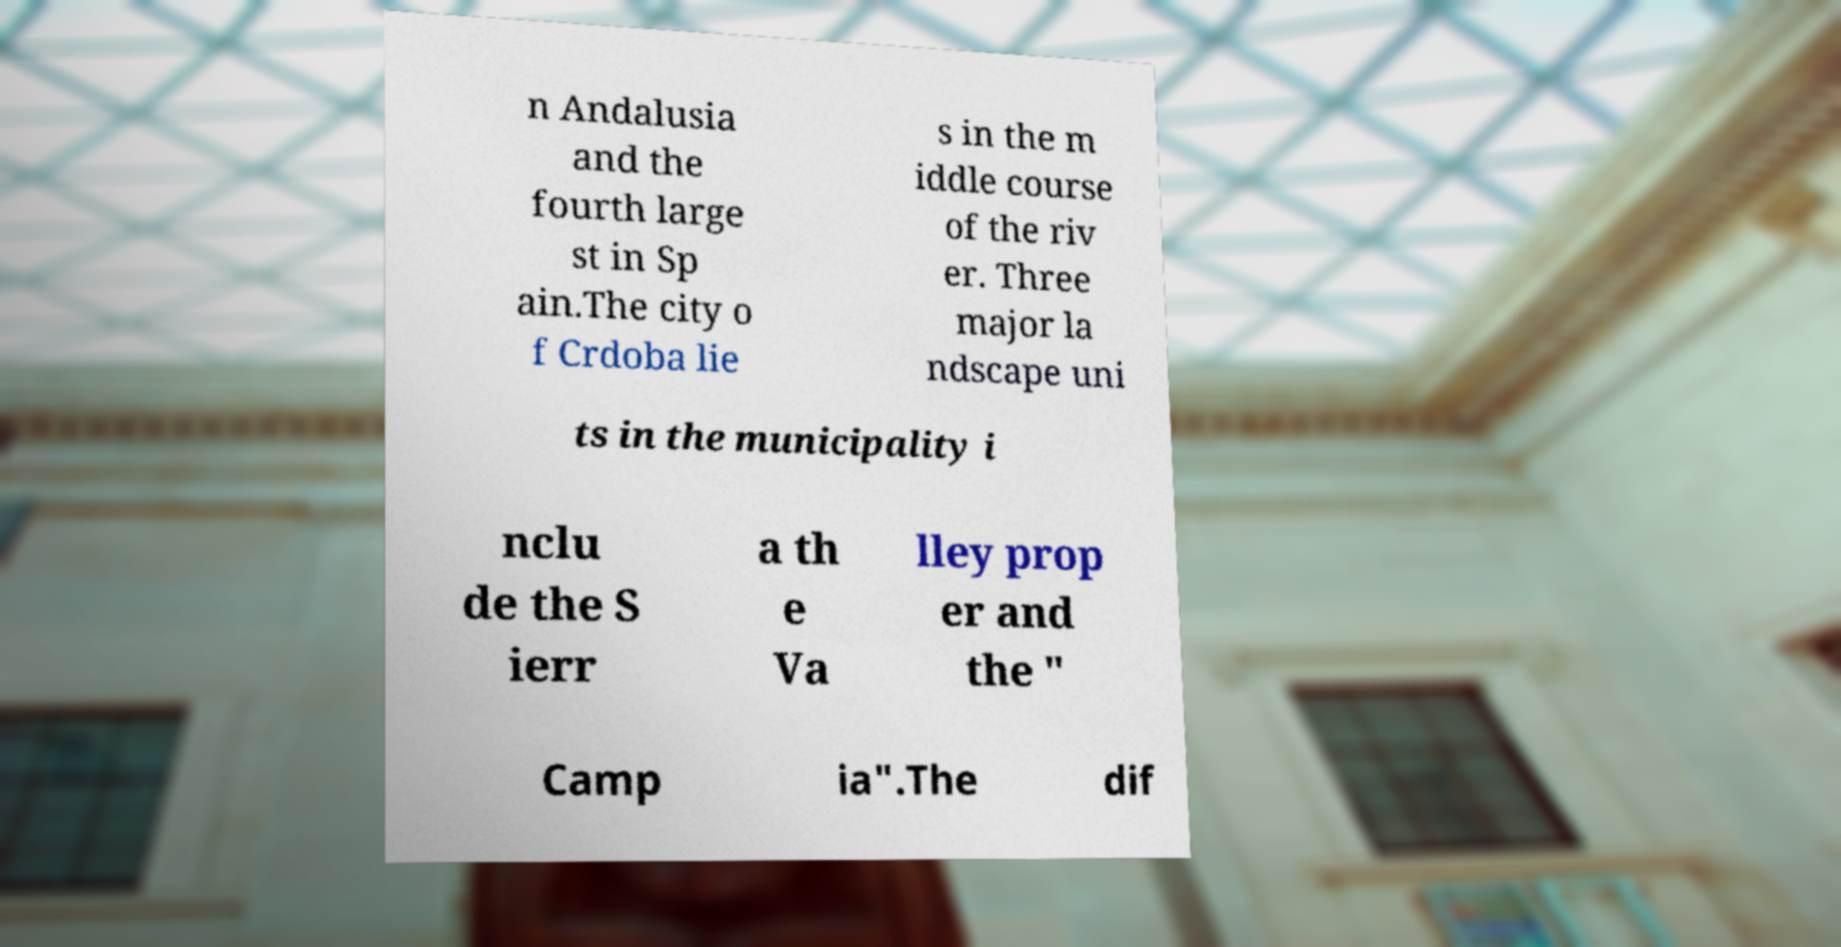What messages or text are displayed in this image? I need them in a readable, typed format. n Andalusia and the fourth large st in Sp ain.The city o f Crdoba lie s in the m iddle course of the riv er. Three major la ndscape uni ts in the municipality i nclu de the S ierr a th e Va lley prop er and the " Camp ia".The dif 